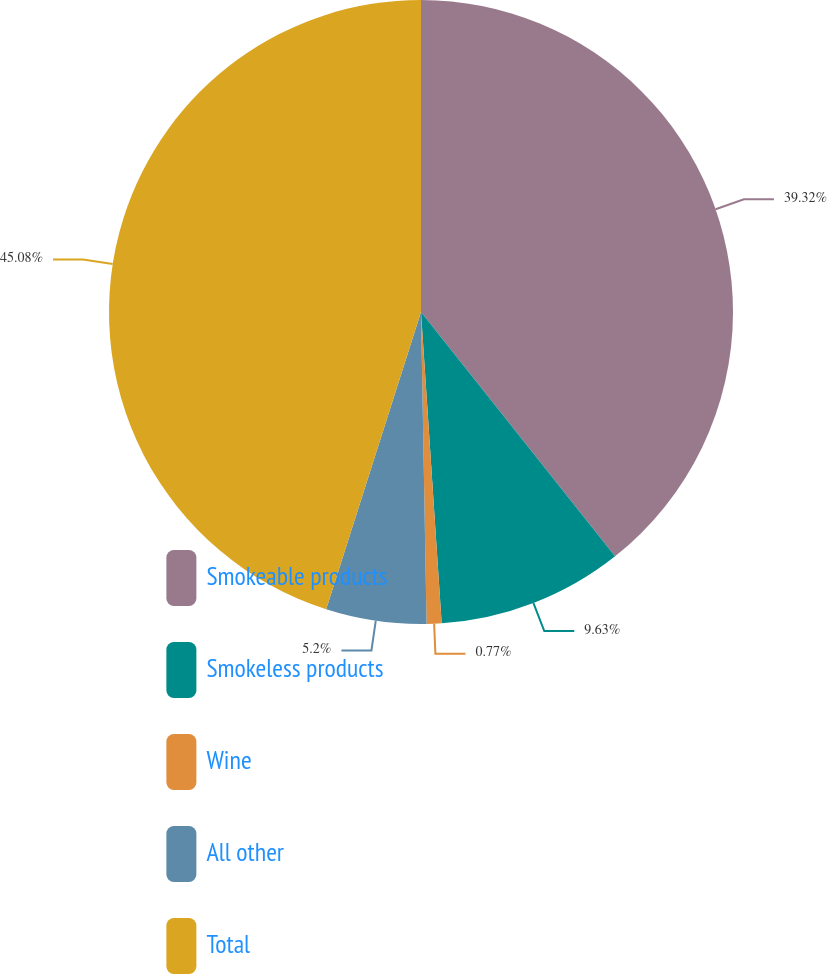Convert chart. <chart><loc_0><loc_0><loc_500><loc_500><pie_chart><fcel>Smokeable products<fcel>Smokeless products<fcel>Wine<fcel>All other<fcel>Total<nl><fcel>39.32%<fcel>9.63%<fcel>0.77%<fcel>5.2%<fcel>45.09%<nl></chart> 